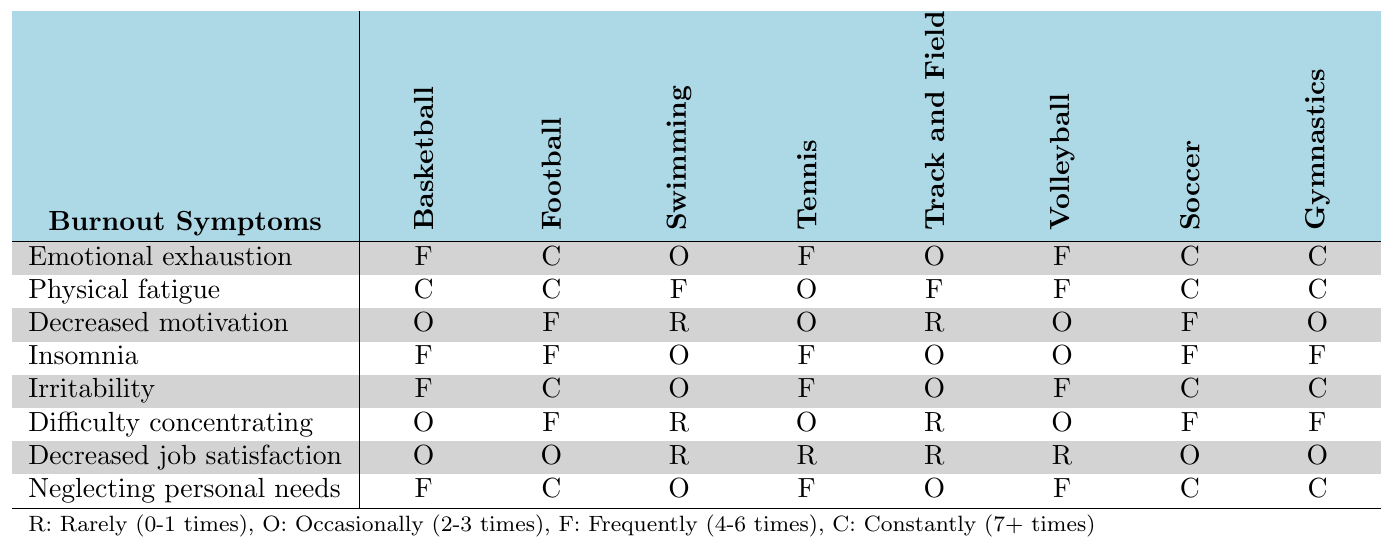What sport has the highest frequency of emotional exhaustion? According to the table, Football has "Constantly (7+ times)" for emotional exhaustion, which is the highest frequency.
Answer: Football Which burnout symptom is most frequently reported among Gymnastics coaches? The highest frequency of burnout symptoms for Gymnastics is "Physical fatigue," which is reported as "Constantly (7+ times)."
Answer: Physical fatigue Is there any sport where coaches experience decreased job satisfaction frequently? Looking at the table, only Football and Soccer have "Occasionally (2-3 times)" for decreased job satisfaction, with no sport reporting this symptom frequently.
Answer: No Which sport has the least frequency of difficulty concentrating? Swimming has the least frequency for difficulty concentrating with "Rarely (0-1 times)."
Answer: Swimming Does any sport report physical fatigue as frequently as Soccer? Soccer reports physical fatigue as "Constantly (7+ times)," while Basketball, Football, and Gymnastics also report physical fatigue the same way.
Answer: Yes What is the average frequency for emotional exhaustion among coaches across all sports? By tallying the frequencies: Basketball (F), Football (C), Swimming (O), Tennis (F), Track and Field (O), Volleyball (F), Soccer (C), Gymnastics (C); we have 3F, 3C, 2O. To convert: F=5 (4-6), C=7 (7+), O=2 (2-3). Thus, average frequency = (5*3 + 7*3 + 2*2)/8 = 5.25.
Answer: Approximately 5.25 Which symptom is most neglected by Swimming coaches? Based on the table, Swimming coaches neglect personal needs with the frequency of "Occasionally (2-3 times)," which is the highest frequency reported.
Answer: Neglecting personal needs How does the frequency of irritability compare between Basketball and Football? Basketball coaches report irritability "Frequently (4-6 times)," while Football coaches report it "Constantly (7+ times)," indicating a higher frequency in Football.
Answer: Football has a higher frequency Which sport has the lowest reported frequency of decreased motivation? The sport with the lowest reported frequency for decreased motivation is Swimming, with "Rarely (0-1 times)."
Answer: Swimming Does the frequency of insomnia vary significantly across sports? Yes, some sports report insomnia as "Frequently (4-6 times)", while others like Swimming and Track and Field report it as "Occasionally (2-3 times)", indicating variability.
Answer: Yes Which sports report emotional exhaustion as frequently as Volleyball? Volleyball reports emotional exhaustion as "Frequently (4-6 times)," while Basketball and Tennis also report it the same way.
Answer: Basketball and Tennis 